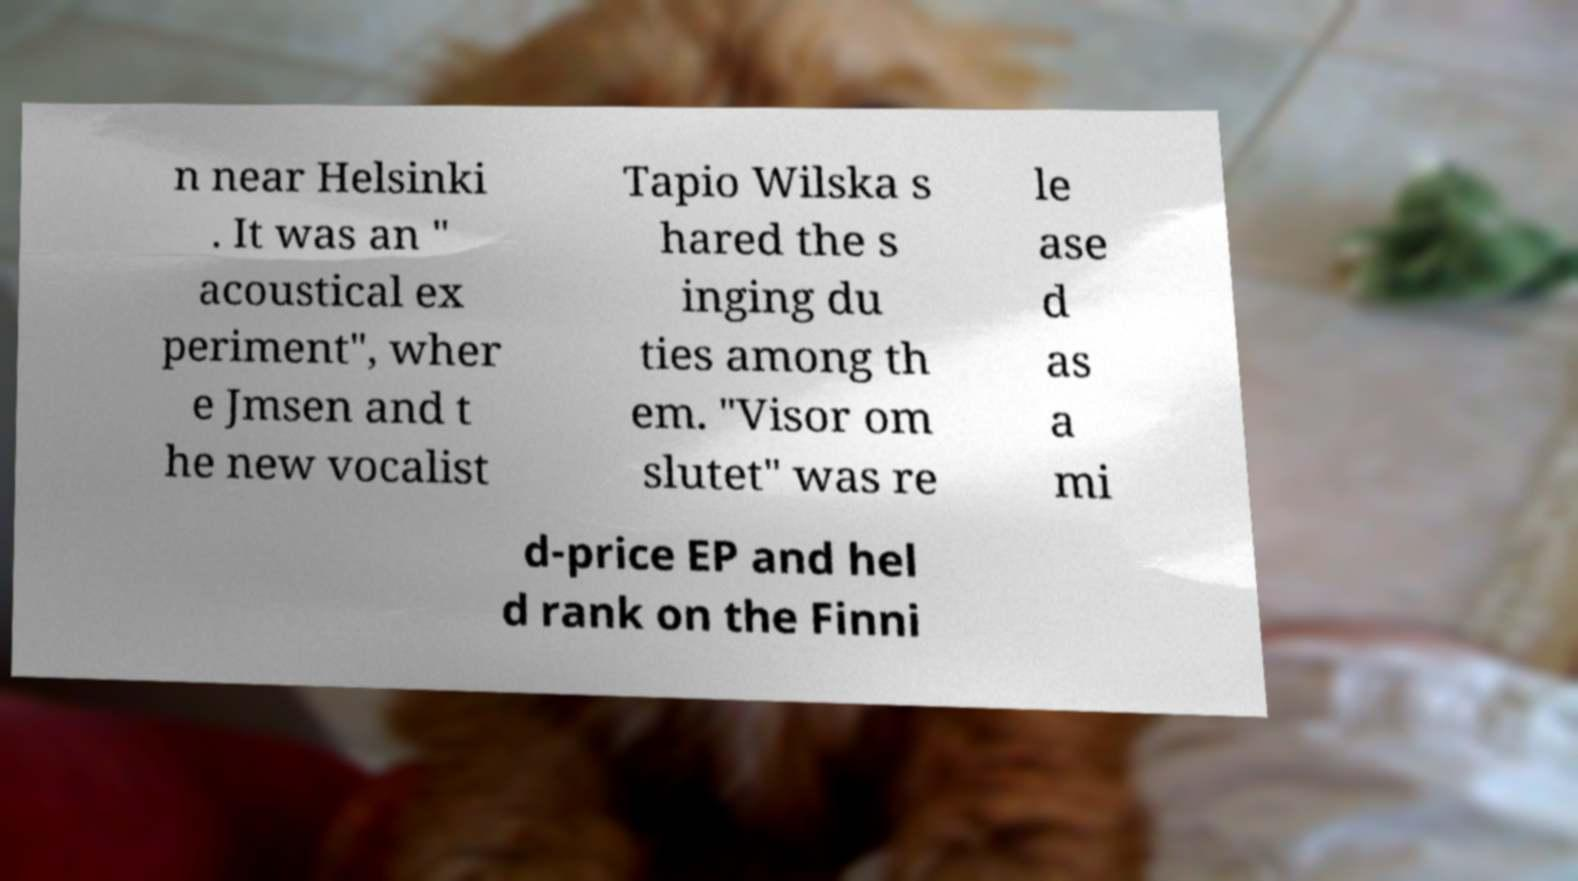There's text embedded in this image that I need extracted. Can you transcribe it verbatim? n near Helsinki . It was an " acoustical ex periment", wher e Jmsen and t he new vocalist Tapio Wilska s hared the s inging du ties among th em. "Visor om slutet" was re le ase d as a mi d-price EP and hel d rank on the Finni 